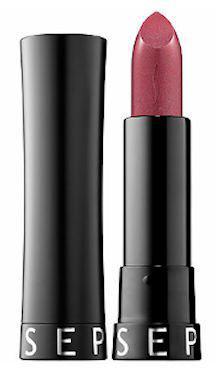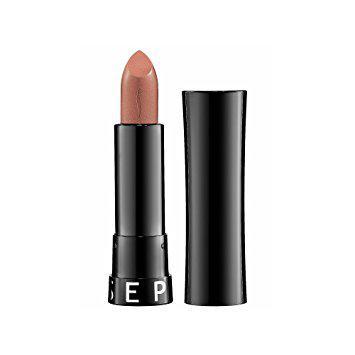The first image is the image on the left, the second image is the image on the right. Analyze the images presented: Is the assertion "Each image shows just one standard lipstick next to only its lid." valid? Answer yes or no. Yes. The first image is the image on the left, the second image is the image on the right. Evaluate the accuracy of this statement regarding the images: "One lipstick has a silver casing and the other has a black casing.". Is it true? Answer yes or no. No. 